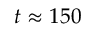<formula> <loc_0><loc_0><loc_500><loc_500>t \approx 1 5 0</formula> 